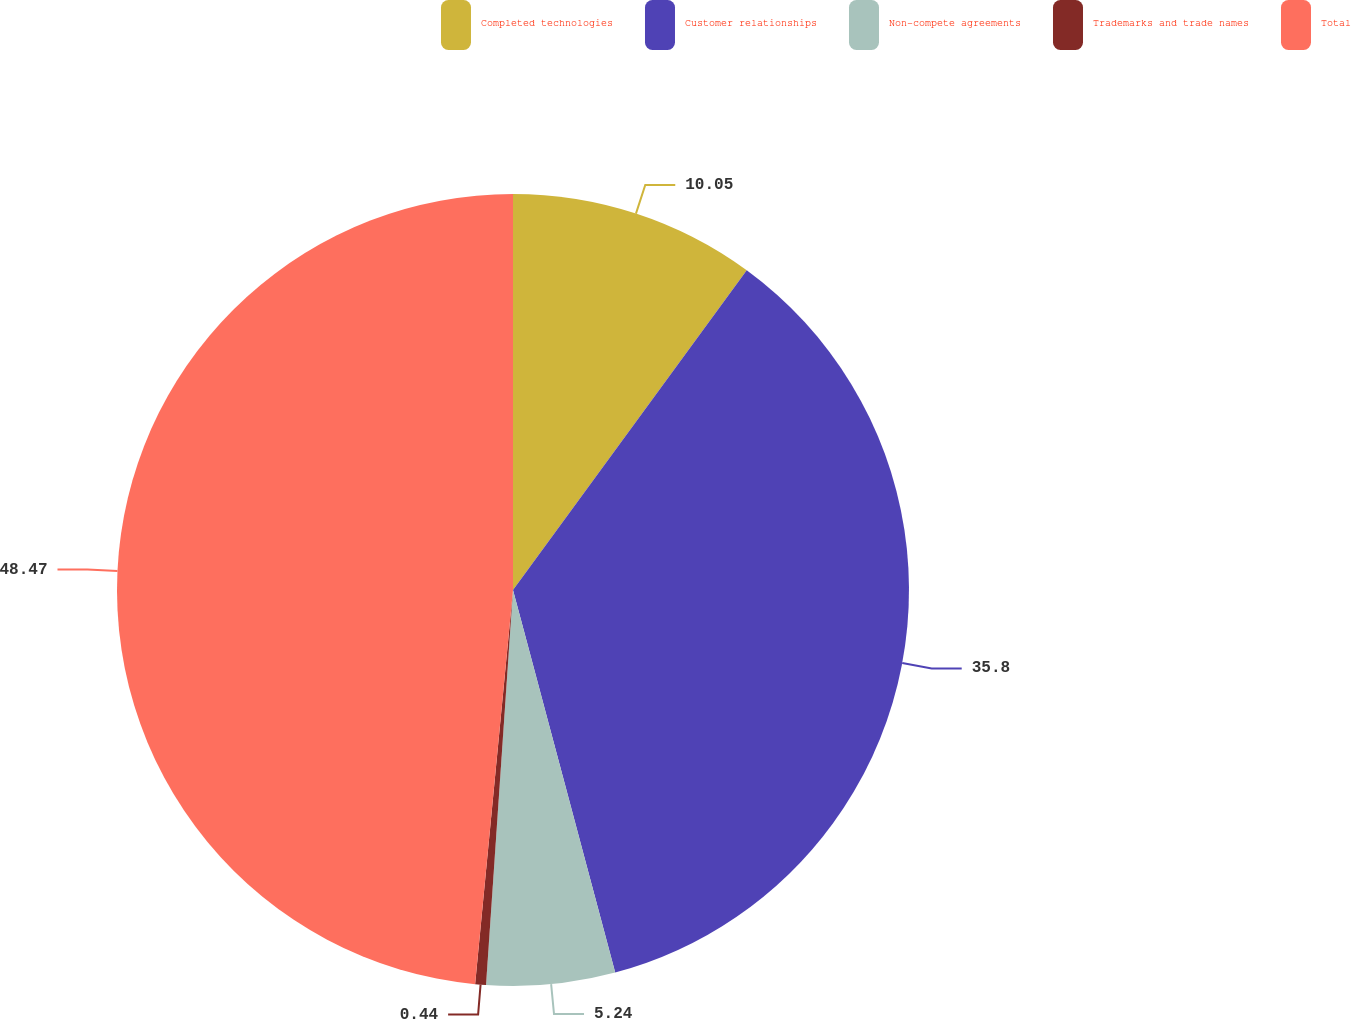Convert chart. <chart><loc_0><loc_0><loc_500><loc_500><pie_chart><fcel>Completed technologies<fcel>Customer relationships<fcel>Non-compete agreements<fcel>Trademarks and trade names<fcel>Total<nl><fcel>10.05%<fcel>35.8%<fcel>5.24%<fcel>0.44%<fcel>48.48%<nl></chart> 